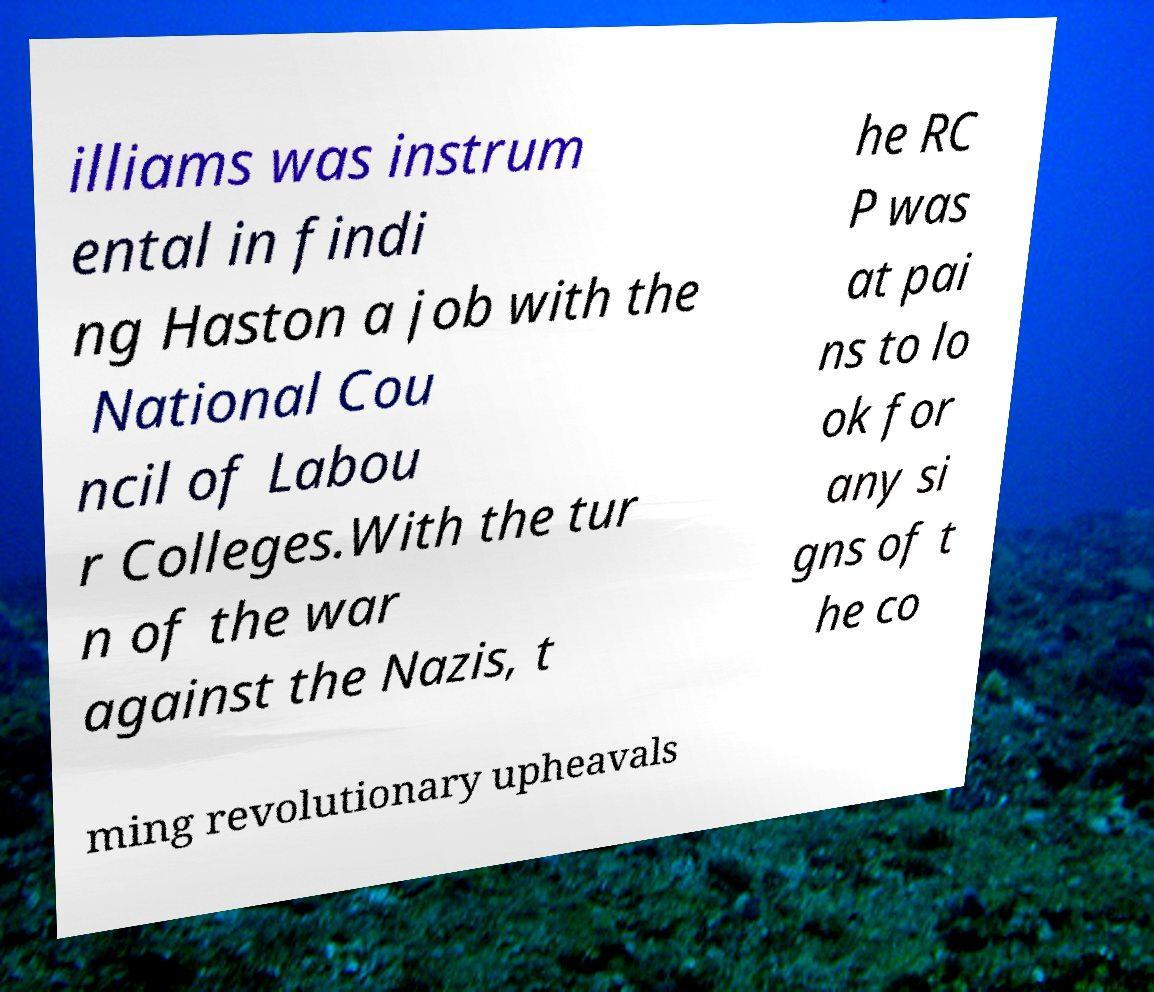What messages or text are displayed in this image? I need them in a readable, typed format. illiams was instrum ental in findi ng Haston a job with the National Cou ncil of Labou r Colleges.With the tur n of the war against the Nazis, t he RC P was at pai ns to lo ok for any si gns of t he co ming revolutionary upheavals 